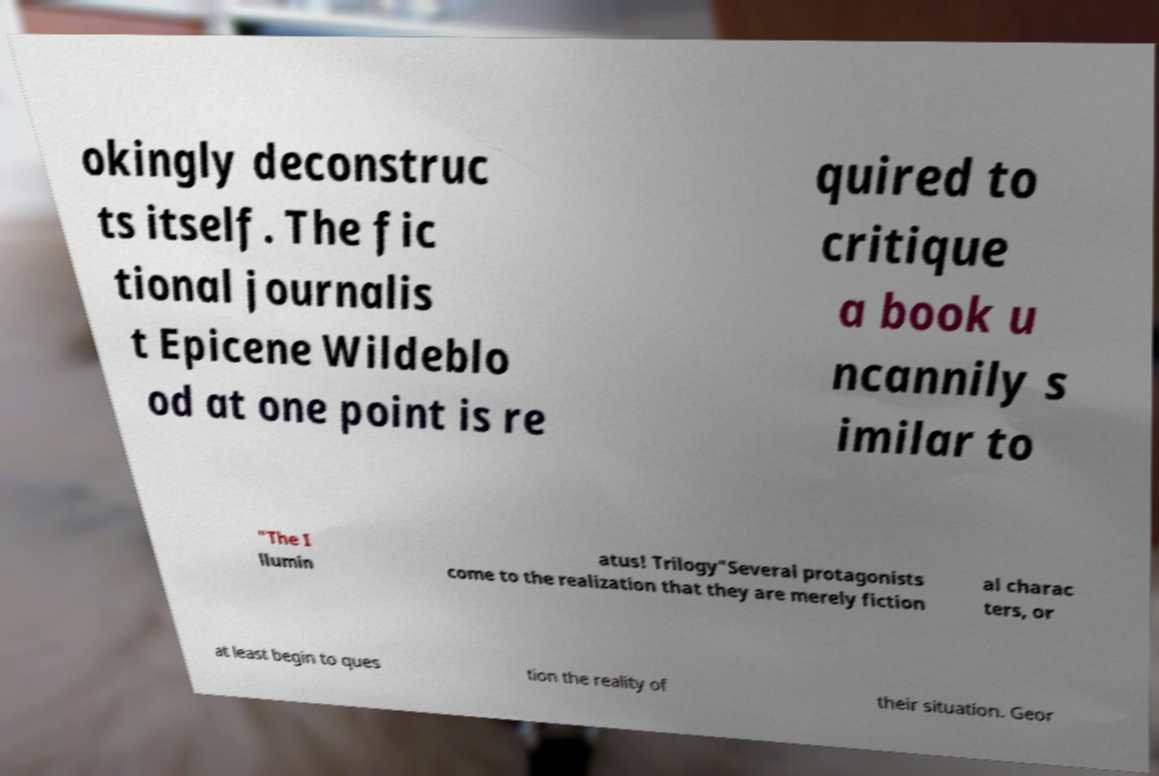Please read and relay the text visible in this image. What does it say? okingly deconstruc ts itself. The fic tional journalis t Epicene Wildeblo od at one point is re quired to critique a book u ncannily s imilar to "The I llumin atus! Trilogy"Several protagonists come to the realization that they are merely fiction al charac ters, or at least begin to ques tion the reality of their situation. Geor 